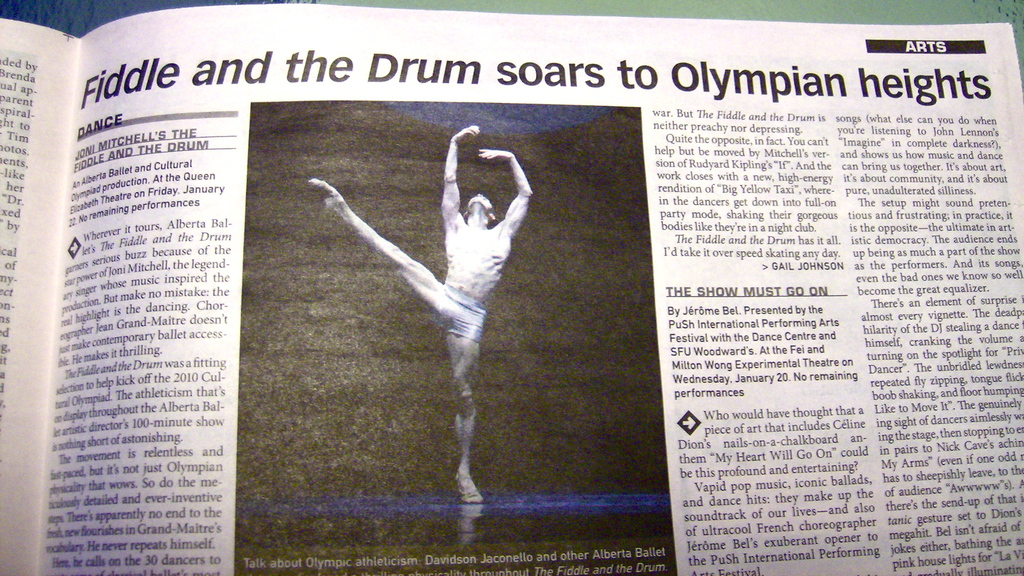What themes does the performance 'Fiddle and the Drum' explore according to the article? The performance 'Fiddle and the Drum' explores themes of war and peace, as it draws inspiration from Joni Mitchell's songs and the poetry of Rudyard Kipling's 'IF', combining song, spoken word, and ballet. 